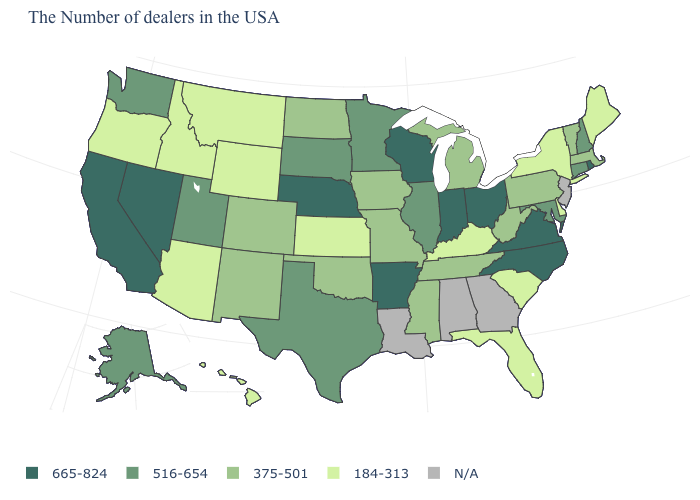Name the states that have a value in the range 375-501?
Answer briefly. Massachusetts, Vermont, Pennsylvania, West Virginia, Michigan, Tennessee, Mississippi, Missouri, Iowa, Oklahoma, North Dakota, Colorado, New Mexico. What is the value of Arizona?
Answer briefly. 184-313. What is the value of Ohio?
Short answer required. 665-824. What is the value of South Carolina?
Quick response, please. 184-313. Which states hav the highest value in the Northeast?
Give a very brief answer. Rhode Island. Does the map have missing data?
Quick response, please. Yes. What is the value of Wisconsin?
Quick response, please. 665-824. Among the states that border Tennessee , which have the lowest value?
Keep it brief. Kentucky. What is the lowest value in the Northeast?
Quick response, please. 184-313. What is the value of Texas?
Write a very short answer. 516-654. What is the highest value in the USA?
Quick response, please. 665-824. Does the first symbol in the legend represent the smallest category?
Quick response, please. No. Name the states that have a value in the range 665-824?
Keep it brief. Rhode Island, Virginia, North Carolina, Ohio, Indiana, Wisconsin, Arkansas, Nebraska, Nevada, California. What is the lowest value in states that border Texas?
Keep it brief. 375-501. Is the legend a continuous bar?
Answer briefly. No. 